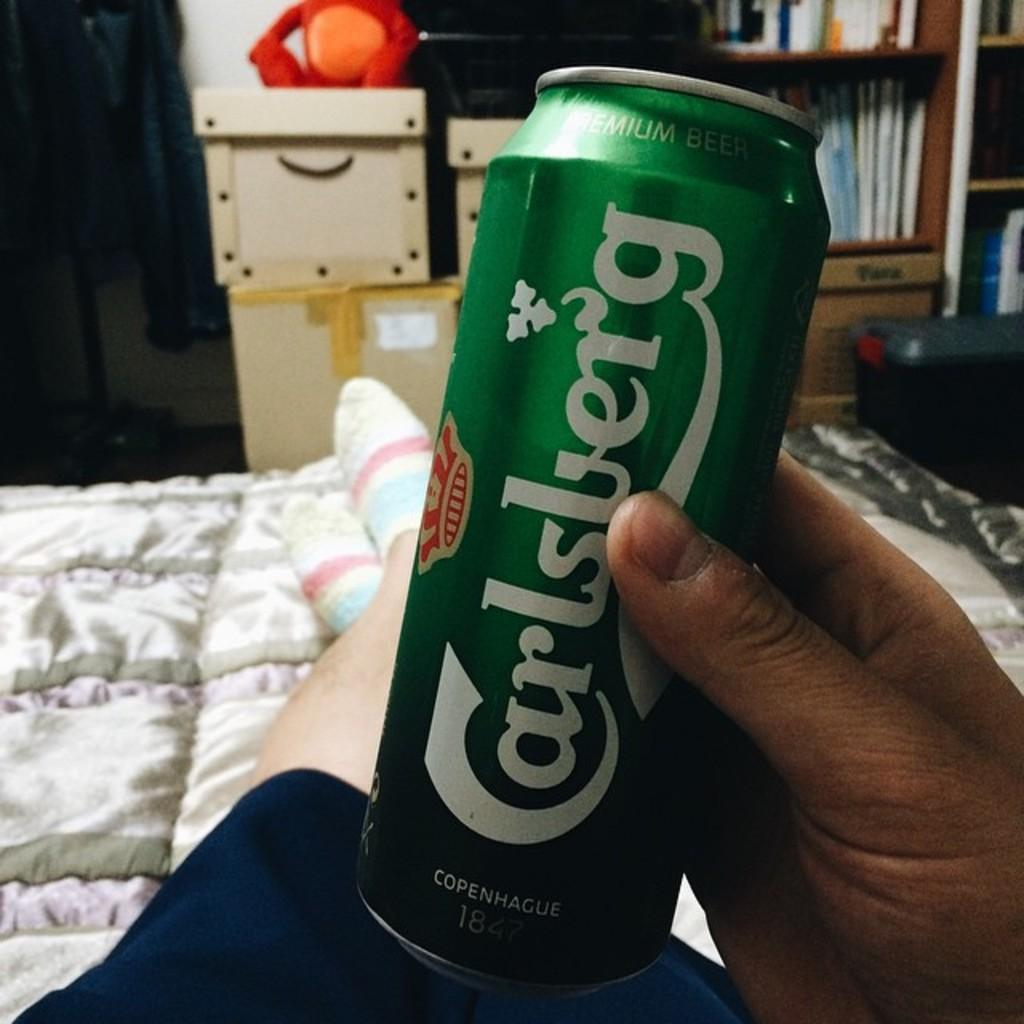<image>
Describe the image concisely. A hand holding a green can of Carlsberg while sitting on a bed. 